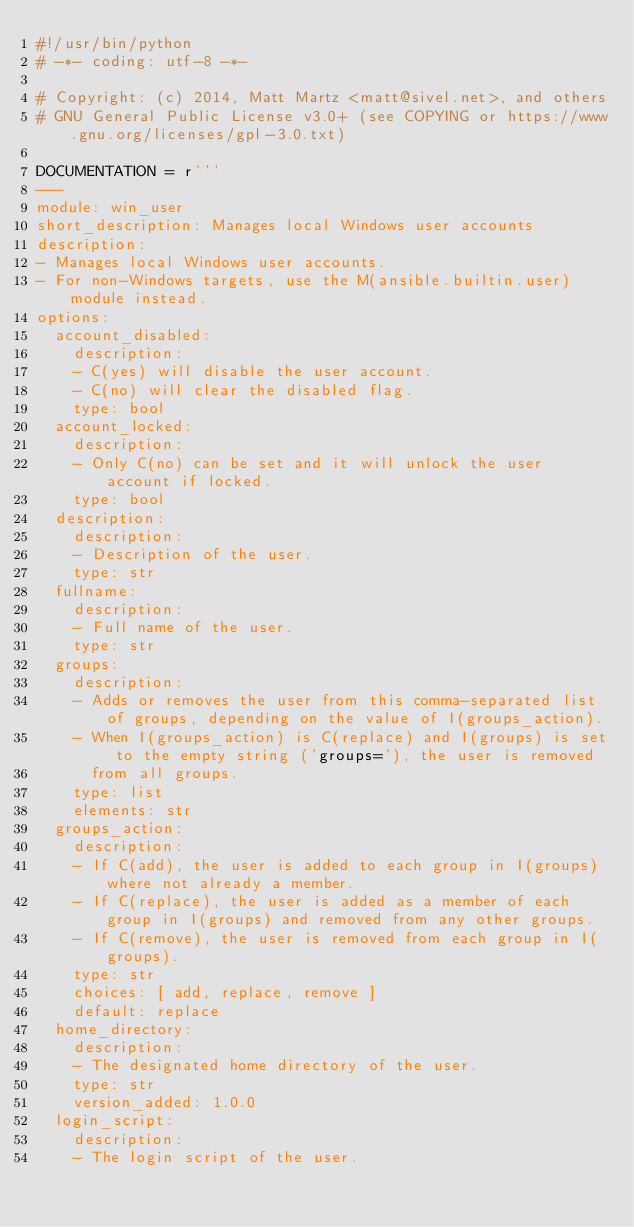Convert code to text. <code><loc_0><loc_0><loc_500><loc_500><_Python_>#!/usr/bin/python
# -*- coding: utf-8 -*-

# Copyright: (c) 2014, Matt Martz <matt@sivel.net>, and others
# GNU General Public License v3.0+ (see COPYING or https://www.gnu.org/licenses/gpl-3.0.txt)

DOCUMENTATION = r'''
---
module: win_user
short_description: Manages local Windows user accounts
description:
- Manages local Windows user accounts.
- For non-Windows targets, use the M(ansible.builtin.user) module instead.
options:
  account_disabled:
    description:
    - C(yes) will disable the user account.
    - C(no) will clear the disabled flag.
    type: bool
  account_locked:
    description:
    - Only C(no) can be set and it will unlock the user account if locked.
    type: bool
  description:
    description:
    - Description of the user.
    type: str
  fullname:
    description:
    - Full name of the user.
    type: str
  groups:
    description:
    - Adds or removes the user from this comma-separated list of groups, depending on the value of I(groups_action).
    - When I(groups_action) is C(replace) and I(groups) is set to the empty string ('groups='), the user is removed
      from all groups.
    type: list
    elements: str
  groups_action:
    description:
    - If C(add), the user is added to each group in I(groups) where not already a member.
    - If C(replace), the user is added as a member of each group in I(groups) and removed from any other groups.
    - If C(remove), the user is removed from each group in I(groups).
    type: str
    choices: [ add, replace, remove ]
    default: replace
  home_directory:
    description:
    - The designated home directory of the user.
    type: str
    version_added: 1.0.0
  login_script:
    description:
    - The login script of the user.</code> 